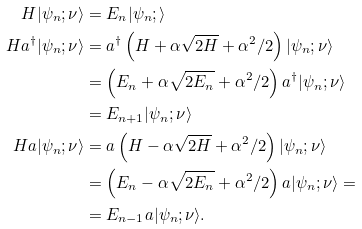<formula> <loc_0><loc_0><loc_500><loc_500>H | \psi _ { n } ; \nu \rangle & = E _ { n } | \psi _ { n } ; \rangle \\ H a ^ { \dagger } | \psi _ { n } ; \nu \rangle & = a ^ { \dagger } \left ( H + \alpha \sqrt { 2 H } + \alpha ^ { 2 } / 2 \right ) | \psi _ { n } ; \nu \rangle \\ & = \left ( E _ { n } + \alpha \sqrt { 2 E _ { n } } + \alpha ^ { 2 } / 2 \right ) a ^ { \dagger } | \psi _ { n } ; \nu \rangle \\ & = E _ { n + 1 } | \psi _ { n } ; \nu \rangle \\ H a | \psi _ { n } ; \nu \rangle & = a \left ( H - \alpha \sqrt { 2 H } + \alpha ^ { 2 } / 2 \right ) | \psi _ { n } ; \nu \rangle \\ & = \left ( E _ { n } - \alpha \sqrt { 2 E _ { n } } + \alpha ^ { 2 } / 2 \right ) a | \psi _ { n } ; \nu \rangle = \\ & = E _ { n - 1 } a | \psi _ { n } ; \nu \rangle . \\</formula> 